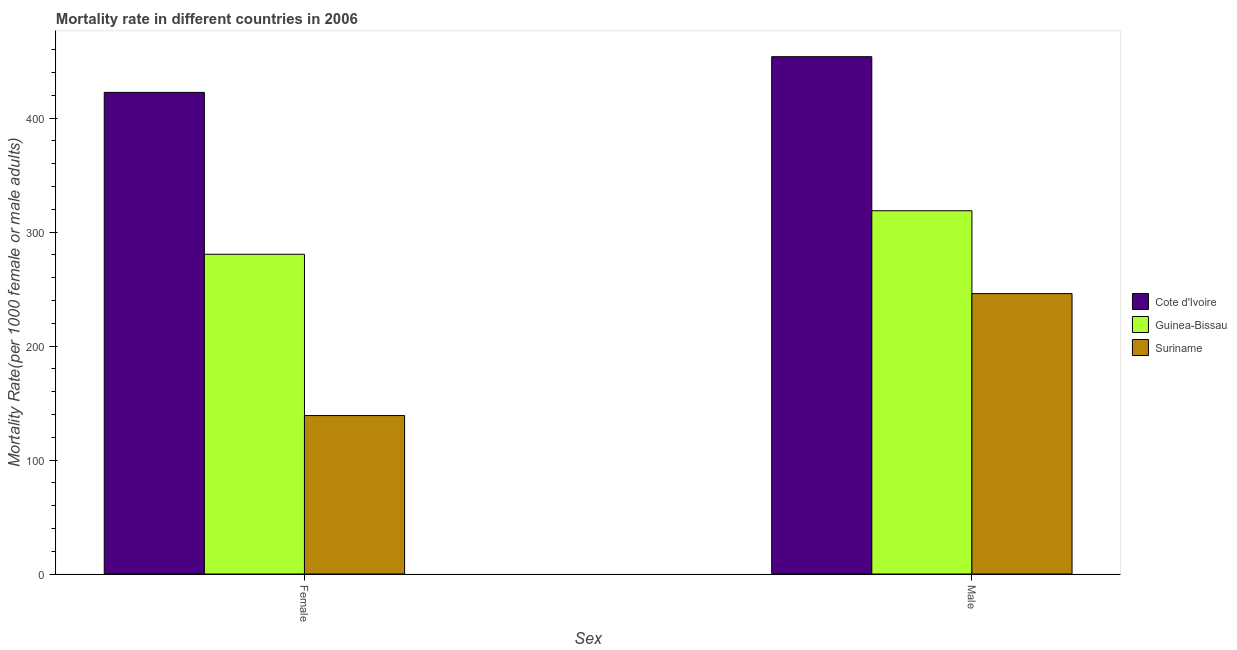How many groups of bars are there?
Provide a short and direct response. 2. Are the number of bars on each tick of the X-axis equal?
Ensure brevity in your answer.  Yes. What is the male mortality rate in Suriname?
Ensure brevity in your answer.  246.03. Across all countries, what is the maximum female mortality rate?
Provide a short and direct response. 422.57. Across all countries, what is the minimum male mortality rate?
Keep it short and to the point. 246.03. In which country was the male mortality rate maximum?
Give a very brief answer. Cote d'Ivoire. In which country was the female mortality rate minimum?
Your answer should be very brief. Suriname. What is the total female mortality rate in the graph?
Give a very brief answer. 842.11. What is the difference between the female mortality rate in Guinea-Bissau and that in Cote d'Ivoire?
Make the answer very short. -142.05. What is the difference between the female mortality rate in Guinea-Bissau and the male mortality rate in Cote d'Ivoire?
Your response must be concise. -173.37. What is the average female mortality rate per country?
Your response must be concise. 280.7. What is the difference between the male mortality rate and female mortality rate in Suriname?
Make the answer very short. 107.01. What is the ratio of the male mortality rate in Cote d'Ivoire to that in Guinea-Bissau?
Your response must be concise. 1.42. Is the female mortality rate in Cote d'Ivoire less than that in Suriname?
Your answer should be very brief. No. In how many countries, is the female mortality rate greater than the average female mortality rate taken over all countries?
Provide a short and direct response. 1. What does the 1st bar from the left in Male represents?
Your answer should be very brief. Cote d'Ivoire. What does the 2nd bar from the right in Male represents?
Provide a succinct answer. Guinea-Bissau. How many bars are there?
Give a very brief answer. 6. Are all the bars in the graph horizontal?
Provide a short and direct response. No. What is the difference between two consecutive major ticks on the Y-axis?
Offer a terse response. 100. Are the values on the major ticks of Y-axis written in scientific E-notation?
Your answer should be compact. No. Does the graph contain grids?
Keep it short and to the point. No. Where does the legend appear in the graph?
Your answer should be compact. Center right. What is the title of the graph?
Give a very brief answer. Mortality rate in different countries in 2006. What is the label or title of the X-axis?
Offer a terse response. Sex. What is the label or title of the Y-axis?
Your answer should be compact. Mortality Rate(per 1000 female or male adults). What is the Mortality Rate(per 1000 female or male adults) of Cote d'Ivoire in Female?
Offer a very short reply. 422.57. What is the Mortality Rate(per 1000 female or male adults) in Guinea-Bissau in Female?
Give a very brief answer. 280.52. What is the Mortality Rate(per 1000 female or male adults) of Suriname in Female?
Offer a very short reply. 139.02. What is the Mortality Rate(per 1000 female or male adults) in Cote d'Ivoire in Male?
Your answer should be very brief. 453.89. What is the Mortality Rate(per 1000 female or male adults) in Guinea-Bissau in Male?
Offer a very short reply. 318.73. What is the Mortality Rate(per 1000 female or male adults) of Suriname in Male?
Your answer should be very brief. 246.03. Across all Sex, what is the maximum Mortality Rate(per 1000 female or male adults) of Cote d'Ivoire?
Keep it short and to the point. 453.89. Across all Sex, what is the maximum Mortality Rate(per 1000 female or male adults) in Guinea-Bissau?
Your answer should be compact. 318.73. Across all Sex, what is the maximum Mortality Rate(per 1000 female or male adults) of Suriname?
Ensure brevity in your answer.  246.03. Across all Sex, what is the minimum Mortality Rate(per 1000 female or male adults) of Cote d'Ivoire?
Ensure brevity in your answer.  422.57. Across all Sex, what is the minimum Mortality Rate(per 1000 female or male adults) of Guinea-Bissau?
Provide a succinct answer. 280.52. Across all Sex, what is the minimum Mortality Rate(per 1000 female or male adults) of Suriname?
Offer a terse response. 139.02. What is the total Mortality Rate(per 1000 female or male adults) of Cote d'Ivoire in the graph?
Your answer should be very brief. 876.46. What is the total Mortality Rate(per 1000 female or male adults) of Guinea-Bissau in the graph?
Make the answer very short. 599.25. What is the total Mortality Rate(per 1000 female or male adults) of Suriname in the graph?
Provide a short and direct response. 385.04. What is the difference between the Mortality Rate(per 1000 female or male adults) of Cote d'Ivoire in Female and that in Male?
Make the answer very short. -31.32. What is the difference between the Mortality Rate(per 1000 female or male adults) in Guinea-Bissau in Female and that in Male?
Your answer should be very brief. -38.2. What is the difference between the Mortality Rate(per 1000 female or male adults) in Suriname in Female and that in Male?
Provide a succinct answer. -107.01. What is the difference between the Mortality Rate(per 1000 female or male adults) of Cote d'Ivoire in Female and the Mortality Rate(per 1000 female or male adults) of Guinea-Bissau in Male?
Offer a very short reply. 103.84. What is the difference between the Mortality Rate(per 1000 female or male adults) in Cote d'Ivoire in Female and the Mortality Rate(per 1000 female or male adults) in Suriname in Male?
Ensure brevity in your answer.  176.54. What is the difference between the Mortality Rate(per 1000 female or male adults) in Guinea-Bissau in Female and the Mortality Rate(per 1000 female or male adults) in Suriname in Male?
Your answer should be compact. 34.5. What is the average Mortality Rate(per 1000 female or male adults) of Cote d'Ivoire per Sex?
Your answer should be very brief. 438.23. What is the average Mortality Rate(per 1000 female or male adults) in Guinea-Bissau per Sex?
Ensure brevity in your answer.  299.63. What is the average Mortality Rate(per 1000 female or male adults) of Suriname per Sex?
Make the answer very short. 192.52. What is the difference between the Mortality Rate(per 1000 female or male adults) in Cote d'Ivoire and Mortality Rate(per 1000 female or male adults) in Guinea-Bissau in Female?
Your answer should be very brief. 142.04. What is the difference between the Mortality Rate(per 1000 female or male adults) of Cote d'Ivoire and Mortality Rate(per 1000 female or male adults) of Suriname in Female?
Your response must be concise. 283.55. What is the difference between the Mortality Rate(per 1000 female or male adults) in Guinea-Bissau and Mortality Rate(per 1000 female or male adults) in Suriname in Female?
Ensure brevity in your answer.  141.51. What is the difference between the Mortality Rate(per 1000 female or male adults) in Cote d'Ivoire and Mortality Rate(per 1000 female or male adults) in Guinea-Bissau in Male?
Your response must be concise. 135.16. What is the difference between the Mortality Rate(per 1000 female or male adults) of Cote d'Ivoire and Mortality Rate(per 1000 female or male adults) of Suriname in Male?
Provide a short and direct response. 207.86. What is the difference between the Mortality Rate(per 1000 female or male adults) of Guinea-Bissau and Mortality Rate(per 1000 female or male adults) of Suriname in Male?
Offer a terse response. 72.7. What is the ratio of the Mortality Rate(per 1000 female or male adults) of Cote d'Ivoire in Female to that in Male?
Make the answer very short. 0.93. What is the ratio of the Mortality Rate(per 1000 female or male adults) of Guinea-Bissau in Female to that in Male?
Offer a terse response. 0.88. What is the ratio of the Mortality Rate(per 1000 female or male adults) of Suriname in Female to that in Male?
Your answer should be very brief. 0.56. What is the difference between the highest and the second highest Mortality Rate(per 1000 female or male adults) of Cote d'Ivoire?
Your answer should be compact. 31.32. What is the difference between the highest and the second highest Mortality Rate(per 1000 female or male adults) of Guinea-Bissau?
Your response must be concise. 38.2. What is the difference between the highest and the second highest Mortality Rate(per 1000 female or male adults) of Suriname?
Your response must be concise. 107.01. What is the difference between the highest and the lowest Mortality Rate(per 1000 female or male adults) in Cote d'Ivoire?
Make the answer very short. 31.32. What is the difference between the highest and the lowest Mortality Rate(per 1000 female or male adults) in Guinea-Bissau?
Provide a short and direct response. 38.2. What is the difference between the highest and the lowest Mortality Rate(per 1000 female or male adults) in Suriname?
Provide a short and direct response. 107.01. 